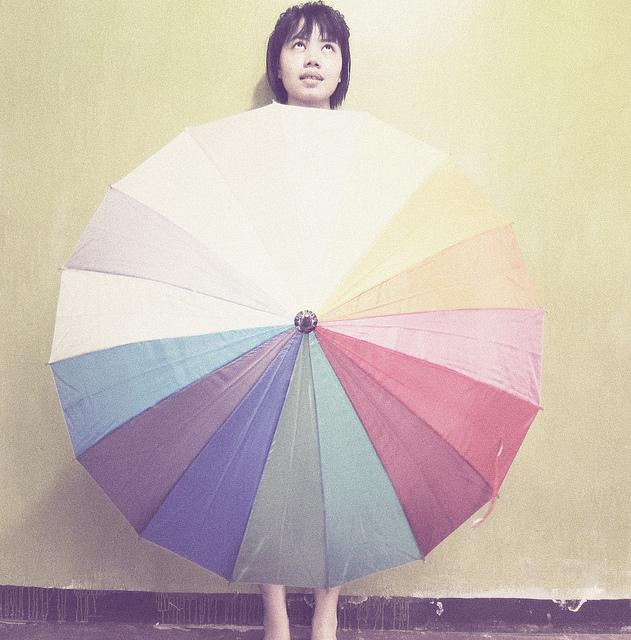How many objects is this person holding?
Answer briefly. 1. What direction is the person looking?
Give a very brief answer. Up. Does the umbrella match the walls and floor?
Quick response, please. No. Where is the umbrella?
Quick response, please. Front. What is behind the girl?
Answer briefly. Wall. How many umbrellas?
Keep it brief. 1. How many panels make up the umbrella?
Be succinct. 16. What is the umbrella blocking?
Give a very brief answer. Woman. What color is the umbrella?
Give a very brief answer. Rainbow. How many umbrellas are there?
Give a very brief answer. 1. What is attached to the umbrellas?
Write a very short answer. Person. Is the umbrella colorful?
Short answer required. Yes. 